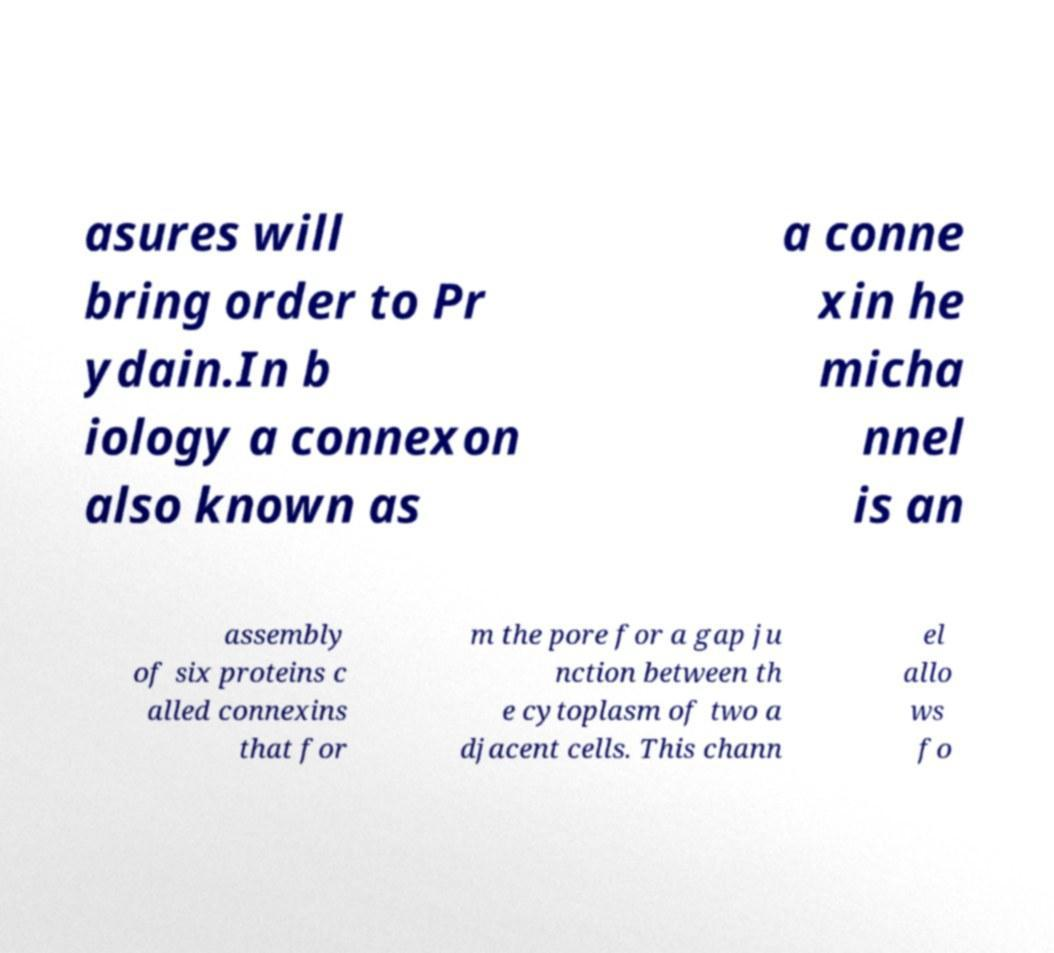Could you assist in decoding the text presented in this image and type it out clearly? asures will bring order to Pr ydain.In b iology a connexon also known as a conne xin he micha nnel is an assembly of six proteins c alled connexins that for m the pore for a gap ju nction between th e cytoplasm of two a djacent cells. This chann el allo ws fo 